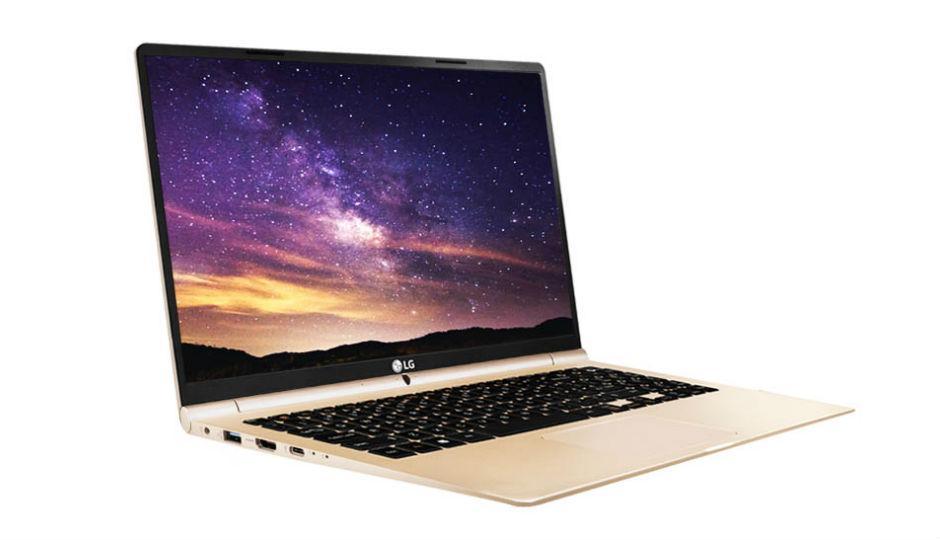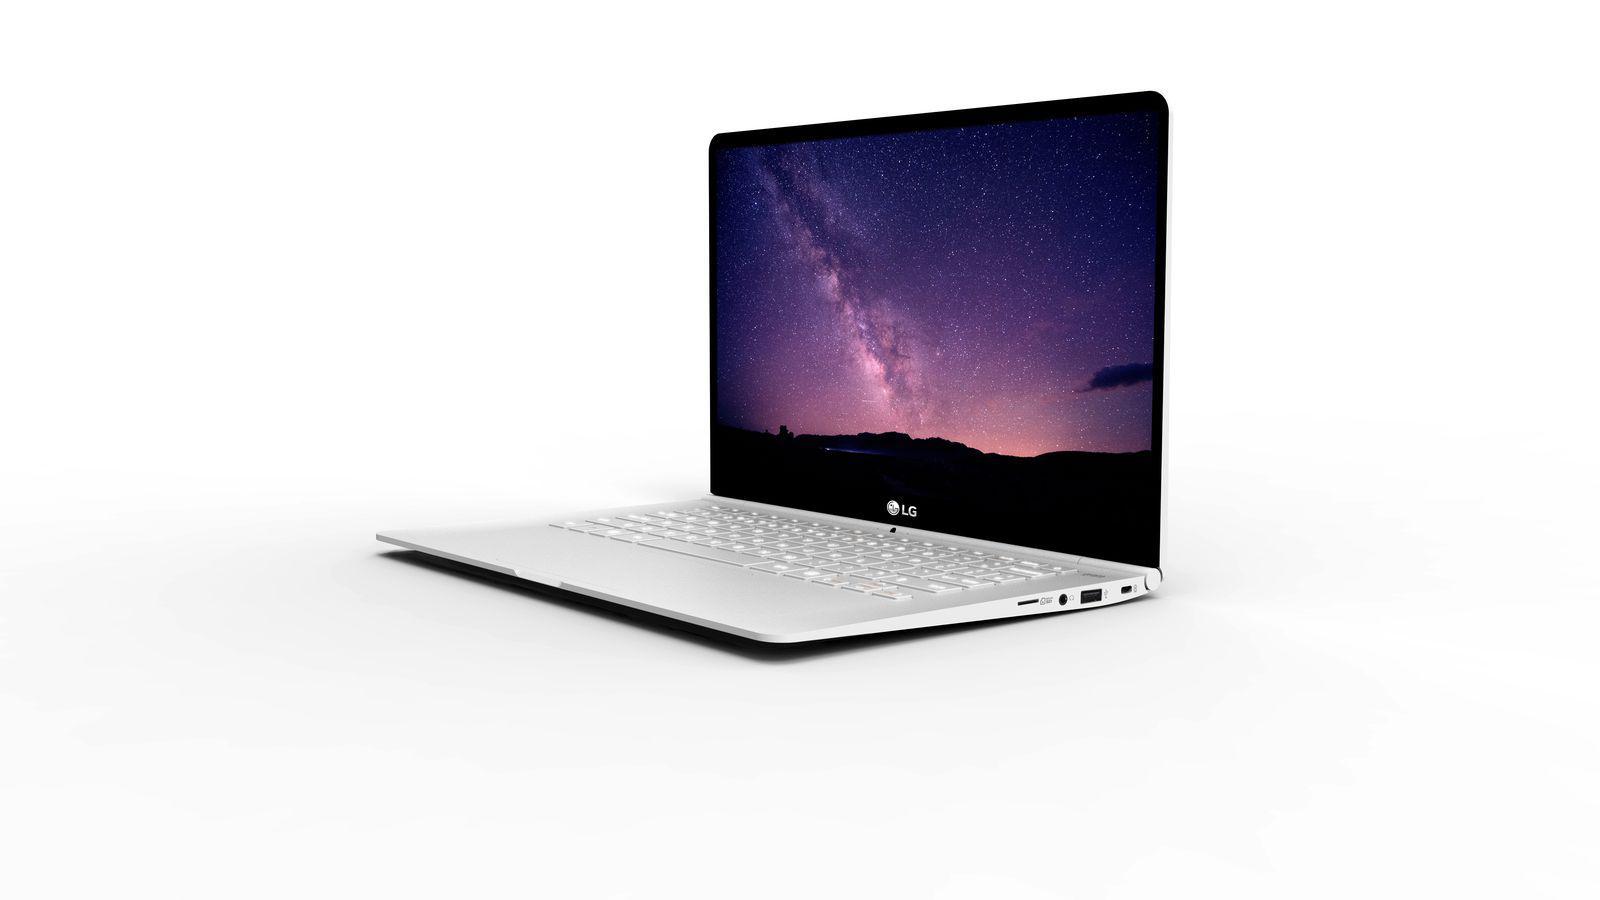The first image is the image on the left, the second image is the image on the right. Analyze the images presented: Is the assertion "Each image contains exactly one open laptop, at least one image contains a laptop with something displayed on its screen, and the laptops on the left and right face different directions." valid? Answer yes or no. Yes. The first image is the image on the left, the second image is the image on the right. For the images displayed, is the sentence "At least one of the laptops has a blank screen." factually correct? Answer yes or no. No. 